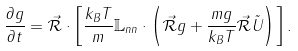Convert formula to latex. <formula><loc_0><loc_0><loc_500><loc_500>\frac { \partial g } { \partial t } = \vec { \mathcal { R } } \cdot \left [ \frac { k _ { B } T } { m } \mathbb { L } _ { n n } \cdot \left ( \vec { \mathcal { R } } g + \frac { m g } { k _ { B } T } \vec { \mathcal { R } } \tilde { U } \right ) \right ] .</formula> 